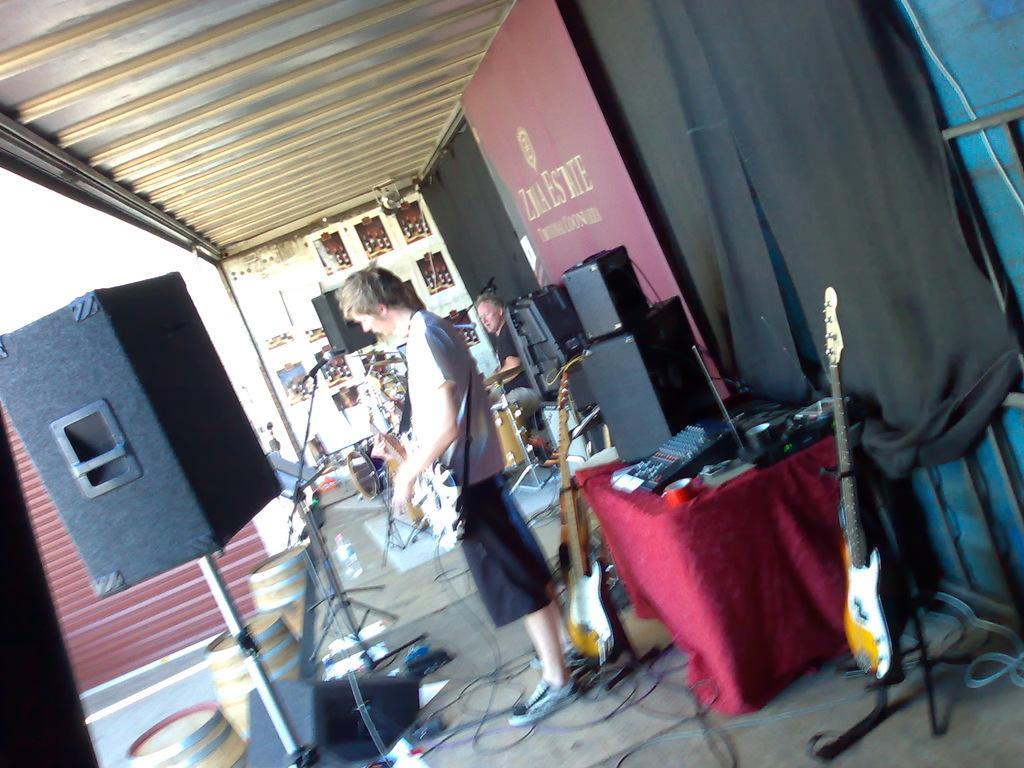Please provide a concise description of this image. In this image we can see person holding guitar, guitars, speakers, person, musical instruments, mic and barrels on the dais. In the background we can see curtain, speaker and wall. 